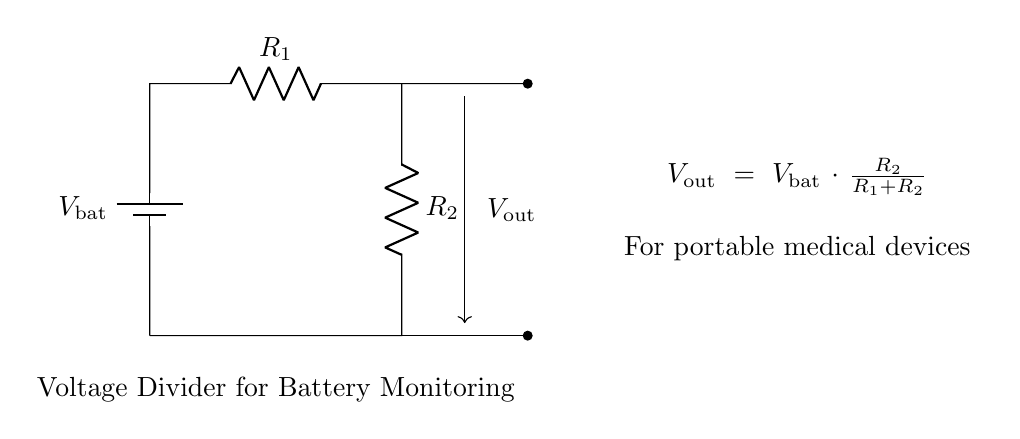What is the total resistance of the circuit? The total resistance in a voltage divider is the sum of the two resistances, R1 and R2. In the diagram, both resistors are in series, so we calculate it as R1 + R2.
Answer: R1 + R2 What is the function of R2 in this circuit? R2 is part of the voltage divider, controlling the output voltage relative to the battery voltage. It determines how much of the input battery voltage appears across it, which is critical for monitoring battery levels.
Answer: Control output voltage What does Vout represent? Vout signifies the output voltage from the voltage divider, which is used for monitoring purposes. It is the voltage across R2 and is derived from the battery voltage.
Answer: Output voltage What happens to Vout if R2 is increased? Increasing R2 will raise Vout, as the output voltage is proportional to the resistance across R2 compared to the total resistance. This results in a higher share of the battery voltage across R2.
Answer: Vout increases What is the purpose of this circuit in portable medical devices? This voltage divider circuit is used to monitor the battery levels, ensuring that medical devices operate efficiently without power interruptions, critical for patient safety.
Answer: Monitor battery levels How is the output voltage calculated? The output voltage (Vout) is calculated using the formula Vout = Vbat multiplied by the ratio of R2 to the total resistance (R1 + R2). This formula gives the voltage that can be measured for battery management.
Answer: Vout = Vbat * (R2 / (R1 + R2)) 